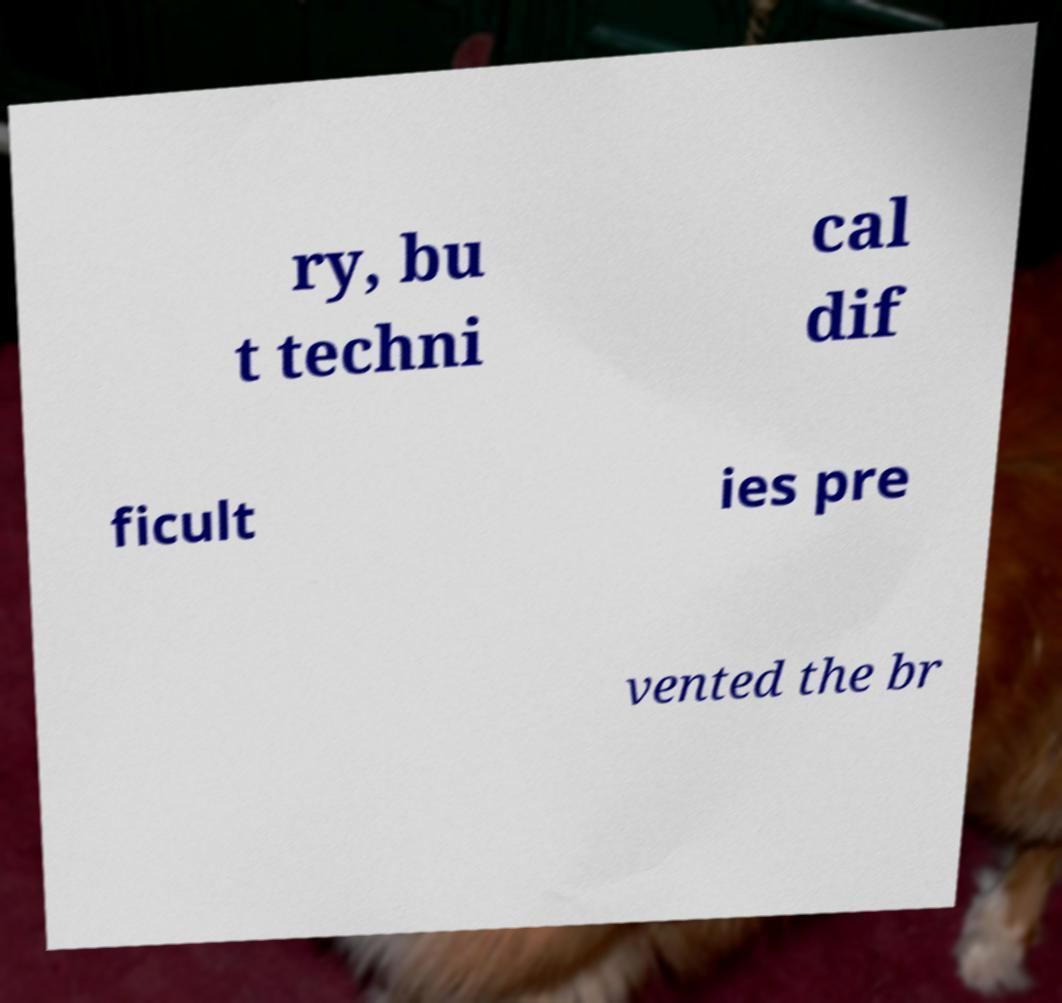Can you read and provide the text displayed in the image?This photo seems to have some interesting text. Can you extract and type it out for me? ry, bu t techni cal dif ficult ies pre vented the br 